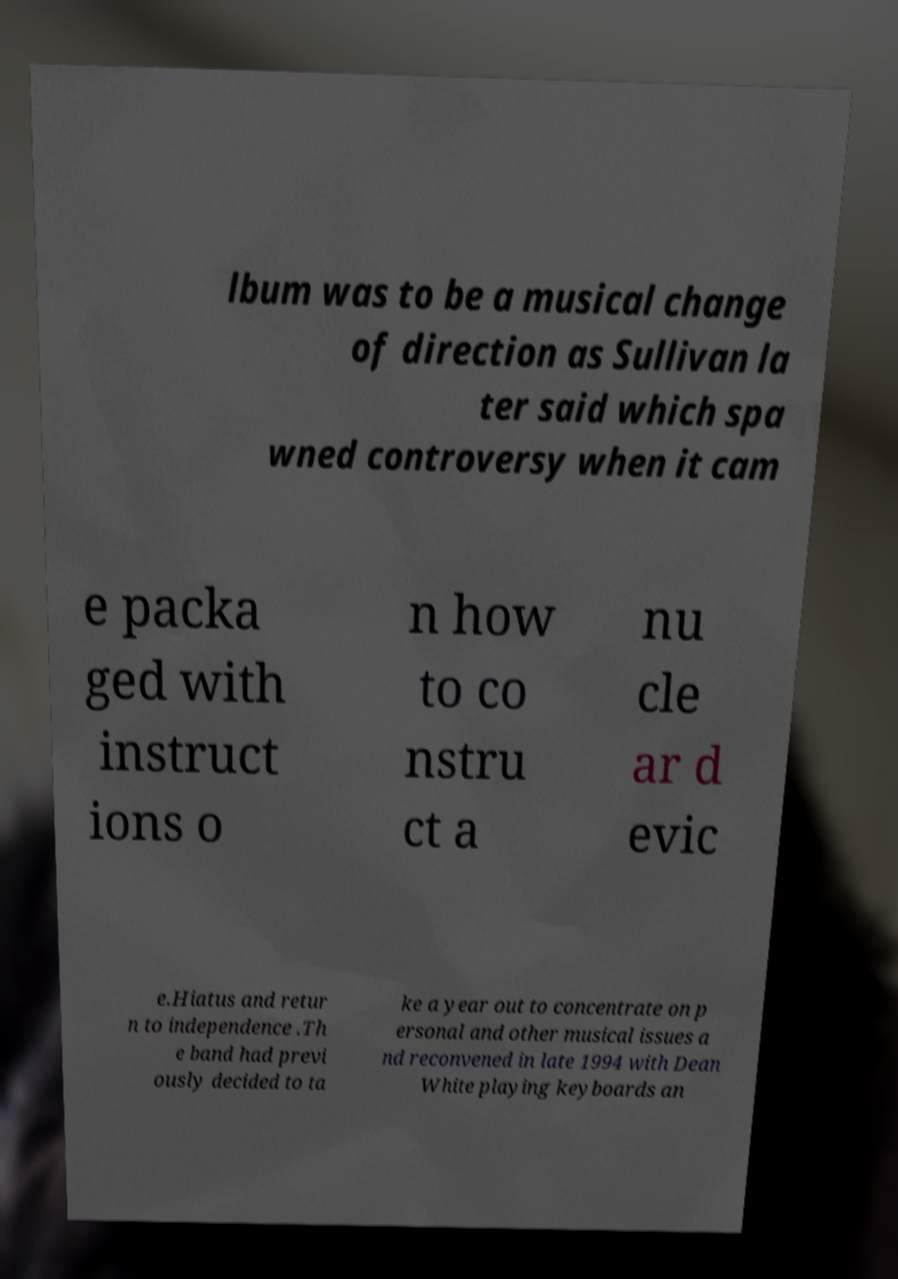Could you extract and type out the text from this image? lbum was to be a musical change of direction as Sullivan la ter said which spa wned controversy when it cam e packa ged with instruct ions o n how to co nstru ct a nu cle ar d evic e.Hiatus and retur n to independence .Th e band had previ ously decided to ta ke a year out to concentrate on p ersonal and other musical issues a nd reconvened in late 1994 with Dean White playing keyboards an 